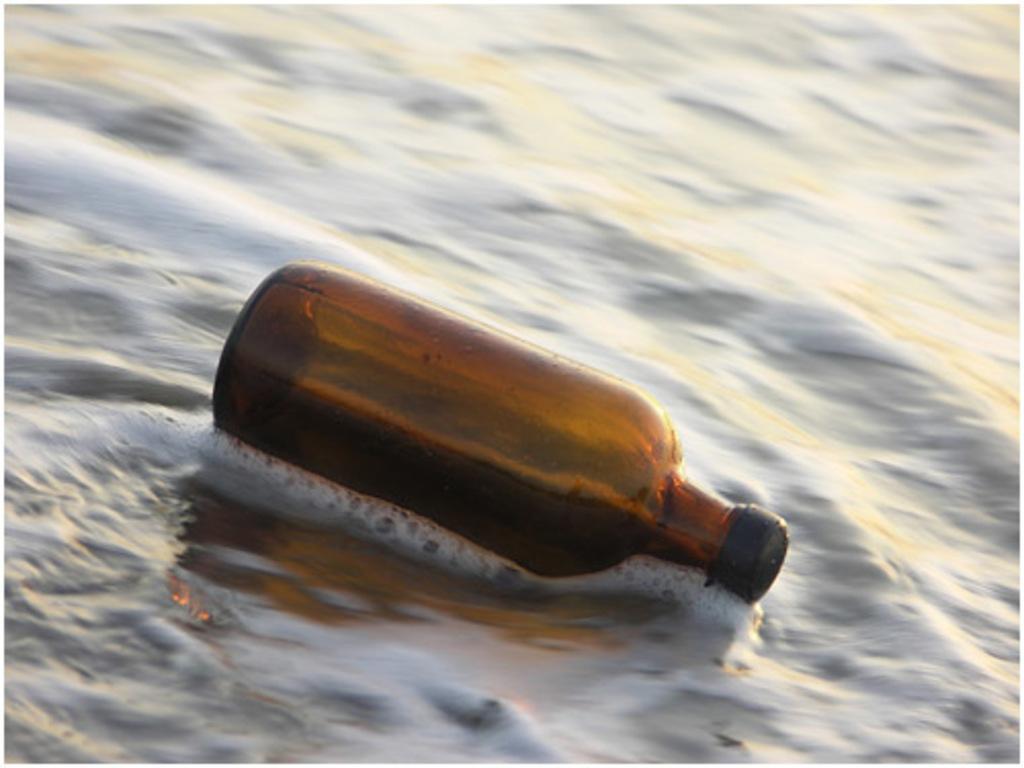Can you describe this image briefly? In this image I can a bottle floating on the water. 